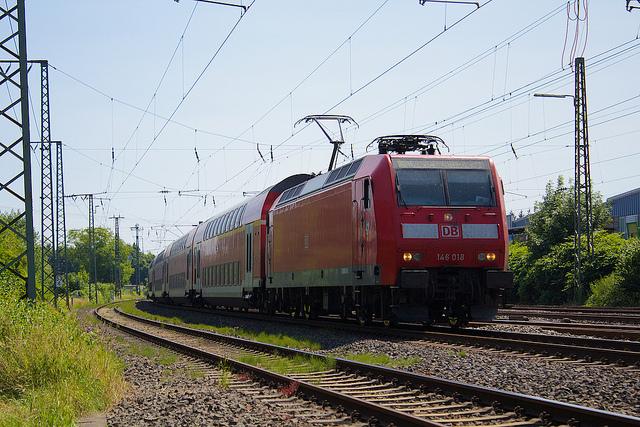Is this train on a bridge?
Keep it brief. No. What color is the train?
Write a very short answer. Red. What area of the world was this taken?
Give a very brief answer. Europe. Where is the power supply for this train located?
Keep it brief. In lines above train. What is the color of the front of the train?
Answer briefly. Red. 